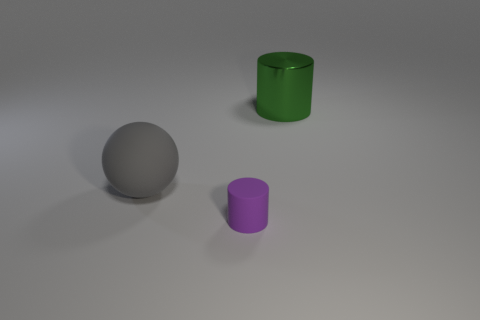Add 1 tiny purple rubber cylinders. How many objects exist? 4 Subtract all balls. How many objects are left? 2 Add 3 big green cylinders. How many big green cylinders are left? 4 Add 3 big objects. How many big objects exist? 5 Subtract 0 red cubes. How many objects are left? 3 Subtract all small gray cubes. Subtract all big gray objects. How many objects are left? 2 